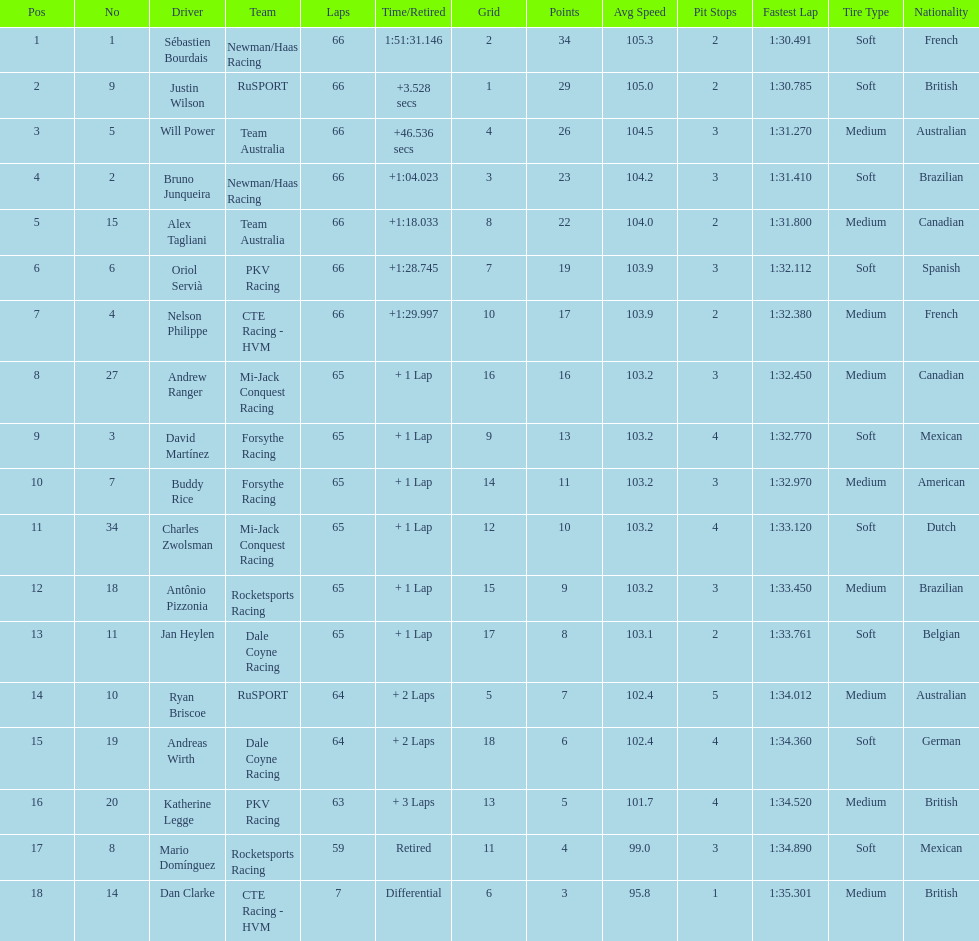Which driver has the same number as his/her position? Sébastien Bourdais. 